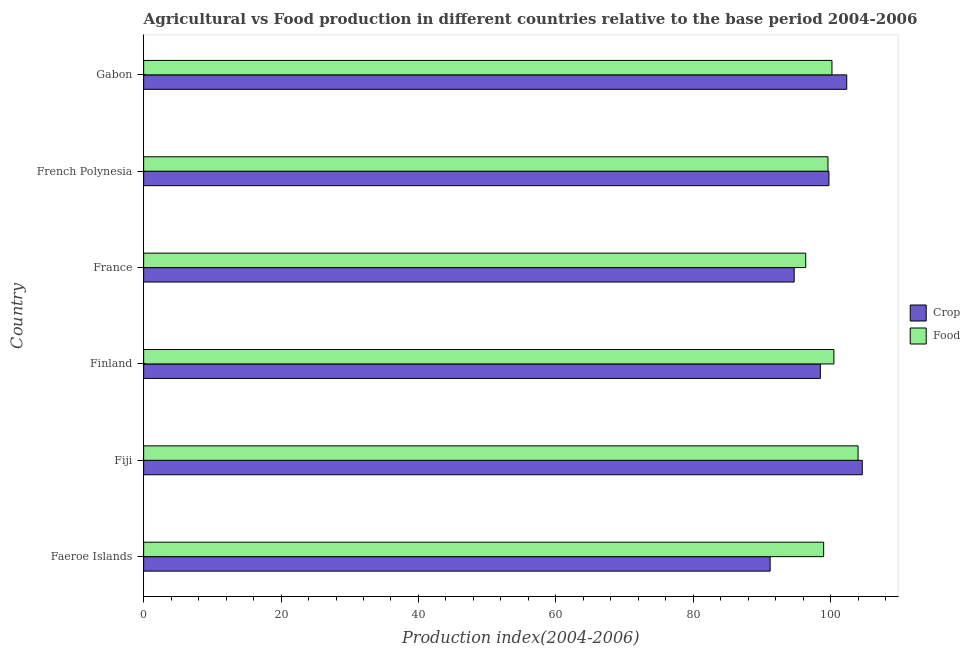Are the number of bars on each tick of the Y-axis equal?
Offer a very short reply. Yes. How many bars are there on the 5th tick from the top?
Offer a terse response. 2. What is the label of the 1st group of bars from the top?
Provide a succinct answer. Gabon. What is the crop production index in Faeroe Islands?
Offer a terse response. 91.19. Across all countries, what is the maximum crop production index?
Offer a terse response. 104.6. Across all countries, what is the minimum food production index?
Keep it short and to the point. 96.37. In which country was the crop production index maximum?
Make the answer very short. Fiji. In which country was the food production index minimum?
Your response must be concise. France. What is the total crop production index in the graph?
Give a very brief answer. 591.07. What is the difference between the food production index in French Polynesia and that in Gabon?
Your answer should be very brief. -0.58. What is the difference between the crop production index in Fiji and the food production index in France?
Your response must be concise. 8.23. What is the average crop production index per country?
Your answer should be very brief. 98.51. What is the difference between the food production index and crop production index in Gabon?
Provide a short and direct response. -2.15. In how many countries, is the food production index greater than 12 ?
Provide a short and direct response. 6. What is the ratio of the food production index in France to that in French Polynesia?
Your response must be concise. 0.97. Is the difference between the food production index in Fiji and Finland greater than the difference between the crop production index in Fiji and Finland?
Give a very brief answer. No. What is the difference between the highest and the second highest food production index?
Offer a very short reply. 3.52. What is the difference between the highest and the lowest food production index?
Offer a terse response. 7.62. In how many countries, is the crop production index greater than the average crop production index taken over all countries?
Ensure brevity in your answer.  3. Is the sum of the food production index in Finland and French Polynesia greater than the maximum crop production index across all countries?
Ensure brevity in your answer.  Yes. What does the 1st bar from the top in French Polynesia represents?
Offer a terse response. Food. What does the 2nd bar from the bottom in Finland represents?
Give a very brief answer. Food. Are all the bars in the graph horizontal?
Provide a succinct answer. Yes. How many countries are there in the graph?
Ensure brevity in your answer.  6. Does the graph contain grids?
Offer a terse response. No. Where does the legend appear in the graph?
Keep it short and to the point. Center right. How are the legend labels stacked?
Offer a very short reply. Vertical. What is the title of the graph?
Keep it short and to the point. Agricultural vs Food production in different countries relative to the base period 2004-2006. What is the label or title of the X-axis?
Your answer should be compact. Production index(2004-2006). What is the Production index(2004-2006) of Crop in Faeroe Islands?
Your answer should be compact. 91.19. What is the Production index(2004-2006) in Food in Faeroe Islands?
Your response must be concise. 98.98. What is the Production index(2004-2006) in Crop in Fiji?
Your response must be concise. 104.6. What is the Production index(2004-2006) of Food in Fiji?
Your answer should be very brief. 103.99. What is the Production index(2004-2006) of Crop in Finland?
Your answer should be compact. 98.5. What is the Production index(2004-2006) in Food in Finland?
Keep it short and to the point. 100.47. What is the Production index(2004-2006) in Crop in France?
Make the answer very short. 94.69. What is the Production index(2004-2006) in Food in France?
Provide a short and direct response. 96.37. What is the Production index(2004-2006) in Crop in French Polynesia?
Keep it short and to the point. 99.75. What is the Production index(2004-2006) in Food in French Polynesia?
Make the answer very short. 99.61. What is the Production index(2004-2006) in Crop in Gabon?
Provide a succinct answer. 102.34. What is the Production index(2004-2006) of Food in Gabon?
Make the answer very short. 100.19. Across all countries, what is the maximum Production index(2004-2006) of Crop?
Your answer should be compact. 104.6. Across all countries, what is the maximum Production index(2004-2006) in Food?
Ensure brevity in your answer.  103.99. Across all countries, what is the minimum Production index(2004-2006) of Crop?
Your answer should be compact. 91.19. Across all countries, what is the minimum Production index(2004-2006) of Food?
Give a very brief answer. 96.37. What is the total Production index(2004-2006) in Crop in the graph?
Offer a very short reply. 591.07. What is the total Production index(2004-2006) in Food in the graph?
Provide a short and direct response. 599.61. What is the difference between the Production index(2004-2006) in Crop in Faeroe Islands and that in Fiji?
Provide a short and direct response. -13.41. What is the difference between the Production index(2004-2006) of Food in Faeroe Islands and that in Fiji?
Make the answer very short. -5.01. What is the difference between the Production index(2004-2006) in Crop in Faeroe Islands and that in Finland?
Make the answer very short. -7.31. What is the difference between the Production index(2004-2006) of Food in Faeroe Islands and that in Finland?
Ensure brevity in your answer.  -1.49. What is the difference between the Production index(2004-2006) of Crop in Faeroe Islands and that in France?
Offer a very short reply. -3.5. What is the difference between the Production index(2004-2006) of Food in Faeroe Islands and that in France?
Provide a short and direct response. 2.61. What is the difference between the Production index(2004-2006) in Crop in Faeroe Islands and that in French Polynesia?
Ensure brevity in your answer.  -8.56. What is the difference between the Production index(2004-2006) in Food in Faeroe Islands and that in French Polynesia?
Provide a succinct answer. -0.63. What is the difference between the Production index(2004-2006) in Crop in Faeroe Islands and that in Gabon?
Your response must be concise. -11.15. What is the difference between the Production index(2004-2006) of Food in Faeroe Islands and that in Gabon?
Your answer should be very brief. -1.21. What is the difference between the Production index(2004-2006) in Food in Fiji and that in Finland?
Ensure brevity in your answer.  3.52. What is the difference between the Production index(2004-2006) in Crop in Fiji and that in France?
Your answer should be compact. 9.91. What is the difference between the Production index(2004-2006) of Food in Fiji and that in France?
Ensure brevity in your answer.  7.62. What is the difference between the Production index(2004-2006) in Crop in Fiji and that in French Polynesia?
Keep it short and to the point. 4.85. What is the difference between the Production index(2004-2006) of Food in Fiji and that in French Polynesia?
Ensure brevity in your answer.  4.38. What is the difference between the Production index(2004-2006) of Crop in Fiji and that in Gabon?
Provide a short and direct response. 2.26. What is the difference between the Production index(2004-2006) of Crop in Finland and that in France?
Your answer should be compact. 3.81. What is the difference between the Production index(2004-2006) of Crop in Finland and that in French Polynesia?
Your answer should be compact. -1.25. What is the difference between the Production index(2004-2006) of Food in Finland and that in French Polynesia?
Your answer should be compact. 0.86. What is the difference between the Production index(2004-2006) of Crop in Finland and that in Gabon?
Offer a very short reply. -3.84. What is the difference between the Production index(2004-2006) of Food in Finland and that in Gabon?
Offer a very short reply. 0.28. What is the difference between the Production index(2004-2006) in Crop in France and that in French Polynesia?
Keep it short and to the point. -5.06. What is the difference between the Production index(2004-2006) in Food in France and that in French Polynesia?
Keep it short and to the point. -3.24. What is the difference between the Production index(2004-2006) in Crop in France and that in Gabon?
Your answer should be compact. -7.65. What is the difference between the Production index(2004-2006) in Food in France and that in Gabon?
Ensure brevity in your answer.  -3.82. What is the difference between the Production index(2004-2006) of Crop in French Polynesia and that in Gabon?
Your response must be concise. -2.59. What is the difference between the Production index(2004-2006) of Food in French Polynesia and that in Gabon?
Make the answer very short. -0.58. What is the difference between the Production index(2004-2006) of Crop in Faeroe Islands and the Production index(2004-2006) of Food in Fiji?
Make the answer very short. -12.8. What is the difference between the Production index(2004-2006) in Crop in Faeroe Islands and the Production index(2004-2006) in Food in Finland?
Your response must be concise. -9.28. What is the difference between the Production index(2004-2006) of Crop in Faeroe Islands and the Production index(2004-2006) of Food in France?
Provide a succinct answer. -5.18. What is the difference between the Production index(2004-2006) of Crop in Faeroe Islands and the Production index(2004-2006) of Food in French Polynesia?
Ensure brevity in your answer.  -8.42. What is the difference between the Production index(2004-2006) of Crop in Fiji and the Production index(2004-2006) of Food in Finland?
Keep it short and to the point. 4.13. What is the difference between the Production index(2004-2006) in Crop in Fiji and the Production index(2004-2006) in Food in France?
Provide a short and direct response. 8.23. What is the difference between the Production index(2004-2006) of Crop in Fiji and the Production index(2004-2006) of Food in French Polynesia?
Provide a succinct answer. 4.99. What is the difference between the Production index(2004-2006) in Crop in Fiji and the Production index(2004-2006) in Food in Gabon?
Ensure brevity in your answer.  4.41. What is the difference between the Production index(2004-2006) of Crop in Finland and the Production index(2004-2006) of Food in France?
Your answer should be compact. 2.13. What is the difference between the Production index(2004-2006) in Crop in Finland and the Production index(2004-2006) in Food in French Polynesia?
Give a very brief answer. -1.11. What is the difference between the Production index(2004-2006) of Crop in Finland and the Production index(2004-2006) of Food in Gabon?
Your answer should be compact. -1.69. What is the difference between the Production index(2004-2006) in Crop in France and the Production index(2004-2006) in Food in French Polynesia?
Give a very brief answer. -4.92. What is the difference between the Production index(2004-2006) of Crop in French Polynesia and the Production index(2004-2006) of Food in Gabon?
Make the answer very short. -0.44. What is the average Production index(2004-2006) of Crop per country?
Ensure brevity in your answer.  98.51. What is the average Production index(2004-2006) of Food per country?
Provide a short and direct response. 99.94. What is the difference between the Production index(2004-2006) in Crop and Production index(2004-2006) in Food in Faeroe Islands?
Provide a succinct answer. -7.79. What is the difference between the Production index(2004-2006) of Crop and Production index(2004-2006) of Food in Fiji?
Give a very brief answer. 0.61. What is the difference between the Production index(2004-2006) of Crop and Production index(2004-2006) of Food in Finland?
Provide a short and direct response. -1.97. What is the difference between the Production index(2004-2006) of Crop and Production index(2004-2006) of Food in France?
Offer a terse response. -1.68. What is the difference between the Production index(2004-2006) in Crop and Production index(2004-2006) in Food in French Polynesia?
Make the answer very short. 0.14. What is the difference between the Production index(2004-2006) in Crop and Production index(2004-2006) in Food in Gabon?
Offer a very short reply. 2.15. What is the ratio of the Production index(2004-2006) of Crop in Faeroe Islands to that in Fiji?
Give a very brief answer. 0.87. What is the ratio of the Production index(2004-2006) in Food in Faeroe Islands to that in Fiji?
Keep it short and to the point. 0.95. What is the ratio of the Production index(2004-2006) in Crop in Faeroe Islands to that in Finland?
Ensure brevity in your answer.  0.93. What is the ratio of the Production index(2004-2006) of Food in Faeroe Islands to that in Finland?
Provide a short and direct response. 0.99. What is the ratio of the Production index(2004-2006) in Food in Faeroe Islands to that in France?
Offer a very short reply. 1.03. What is the ratio of the Production index(2004-2006) in Crop in Faeroe Islands to that in French Polynesia?
Your response must be concise. 0.91. What is the ratio of the Production index(2004-2006) in Crop in Faeroe Islands to that in Gabon?
Offer a very short reply. 0.89. What is the ratio of the Production index(2004-2006) in Food in Faeroe Islands to that in Gabon?
Make the answer very short. 0.99. What is the ratio of the Production index(2004-2006) in Crop in Fiji to that in Finland?
Provide a short and direct response. 1.06. What is the ratio of the Production index(2004-2006) in Food in Fiji to that in Finland?
Provide a succinct answer. 1.03. What is the ratio of the Production index(2004-2006) of Crop in Fiji to that in France?
Your answer should be very brief. 1.1. What is the ratio of the Production index(2004-2006) in Food in Fiji to that in France?
Your answer should be compact. 1.08. What is the ratio of the Production index(2004-2006) in Crop in Fiji to that in French Polynesia?
Your answer should be compact. 1.05. What is the ratio of the Production index(2004-2006) in Food in Fiji to that in French Polynesia?
Offer a very short reply. 1.04. What is the ratio of the Production index(2004-2006) in Crop in Fiji to that in Gabon?
Your response must be concise. 1.02. What is the ratio of the Production index(2004-2006) in Food in Fiji to that in Gabon?
Offer a terse response. 1.04. What is the ratio of the Production index(2004-2006) of Crop in Finland to that in France?
Offer a very short reply. 1.04. What is the ratio of the Production index(2004-2006) in Food in Finland to that in France?
Keep it short and to the point. 1.04. What is the ratio of the Production index(2004-2006) in Crop in Finland to that in French Polynesia?
Your response must be concise. 0.99. What is the ratio of the Production index(2004-2006) of Food in Finland to that in French Polynesia?
Your answer should be very brief. 1.01. What is the ratio of the Production index(2004-2006) in Crop in Finland to that in Gabon?
Keep it short and to the point. 0.96. What is the ratio of the Production index(2004-2006) of Crop in France to that in French Polynesia?
Your answer should be compact. 0.95. What is the ratio of the Production index(2004-2006) in Food in France to that in French Polynesia?
Provide a succinct answer. 0.97. What is the ratio of the Production index(2004-2006) in Crop in France to that in Gabon?
Make the answer very short. 0.93. What is the ratio of the Production index(2004-2006) in Food in France to that in Gabon?
Offer a terse response. 0.96. What is the ratio of the Production index(2004-2006) of Crop in French Polynesia to that in Gabon?
Offer a very short reply. 0.97. What is the ratio of the Production index(2004-2006) in Food in French Polynesia to that in Gabon?
Your answer should be very brief. 0.99. What is the difference between the highest and the second highest Production index(2004-2006) of Crop?
Your answer should be very brief. 2.26. What is the difference between the highest and the second highest Production index(2004-2006) in Food?
Offer a very short reply. 3.52. What is the difference between the highest and the lowest Production index(2004-2006) in Crop?
Offer a terse response. 13.41. What is the difference between the highest and the lowest Production index(2004-2006) of Food?
Your response must be concise. 7.62. 